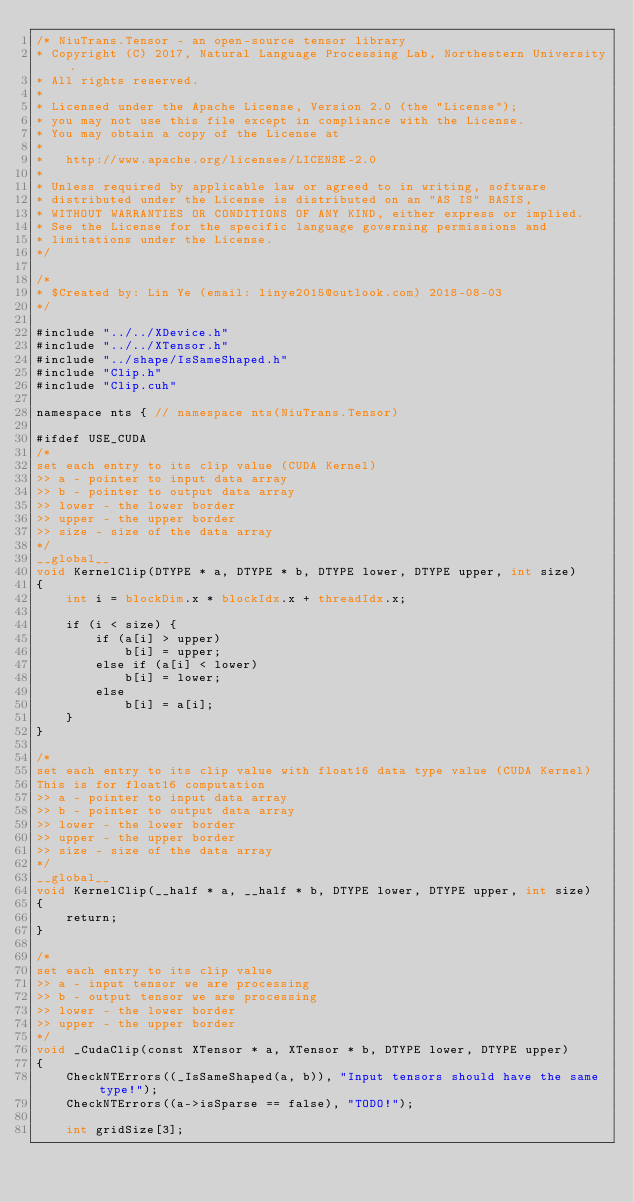<code> <loc_0><loc_0><loc_500><loc_500><_Cuda_>/* NiuTrans.Tensor - an open-source tensor library
* Copyright (C) 2017, Natural Language Processing Lab, Northestern University.
* All rights reserved.
*
* Licensed under the Apache License, Version 2.0 (the "License");
* you may not use this file except in compliance with the License.
* You may obtain a copy of the License at
*
*   http://www.apache.org/licenses/LICENSE-2.0
*
* Unless required by applicable law or agreed to in writing, software
* distributed under the License is distributed on an "AS IS" BASIS,
* WITHOUT WARRANTIES OR CONDITIONS OF ANY KIND, either express or implied.
* See the License for the specific language governing permissions and
* limitations under the License.
*/

/*
* $Created by: Lin Ye (email: linye2015@outlook.com) 2018-08-03
*/

#include "../../XDevice.h"
#include "../../XTensor.h"
#include "../shape/IsSameShaped.h"
#include "Clip.h"
#include "Clip.cuh"

namespace nts { // namespace nts(NiuTrans.Tensor)

#ifdef USE_CUDA
/*
set each entry to its clip value (CUDA Kernel)
>> a - pointer to input data array
>> b - pointer to output data array
>> lower - the lower border
>> upper - the upper border
>> size - size of the data array
*/
__global__
void KernelClip(DTYPE * a, DTYPE * b, DTYPE lower, DTYPE upper, int size)
{
    int i = blockDim.x * blockIdx.x + threadIdx.x;

    if (i < size) {
        if (a[i] > upper)
            b[i] = upper;
        else if (a[i] < lower)
            b[i] = lower;
        else
            b[i] = a[i];
    }
}

/*
set each entry to its clip value with float16 data type value (CUDA Kernel)
This is for float16 computation
>> a - pointer to input data array
>> b - pointer to output data array
>> lower - the lower border
>> upper - the upper border
>> size - size of the data array
*/
__global__
void KernelClip(__half * a, __half * b, DTYPE lower, DTYPE upper, int size)
{
    return;
}

/*
set each entry to its clip value
>> a - input tensor we are processing
>> b - output tensor we are processing
>> lower - the lower border
>> upper - the upper border
*/
void _CudaClip(const XTensor * a, XTensor * b, DTYPE lower, DTYPE upper)
{
    CheckNTErrors((_IsSameShaped(a, b)), "Input tensors should have the same type!");
    CheckNTErrors((a->isSparse == false), "TODO!");

    int gridSize[3];</code> 